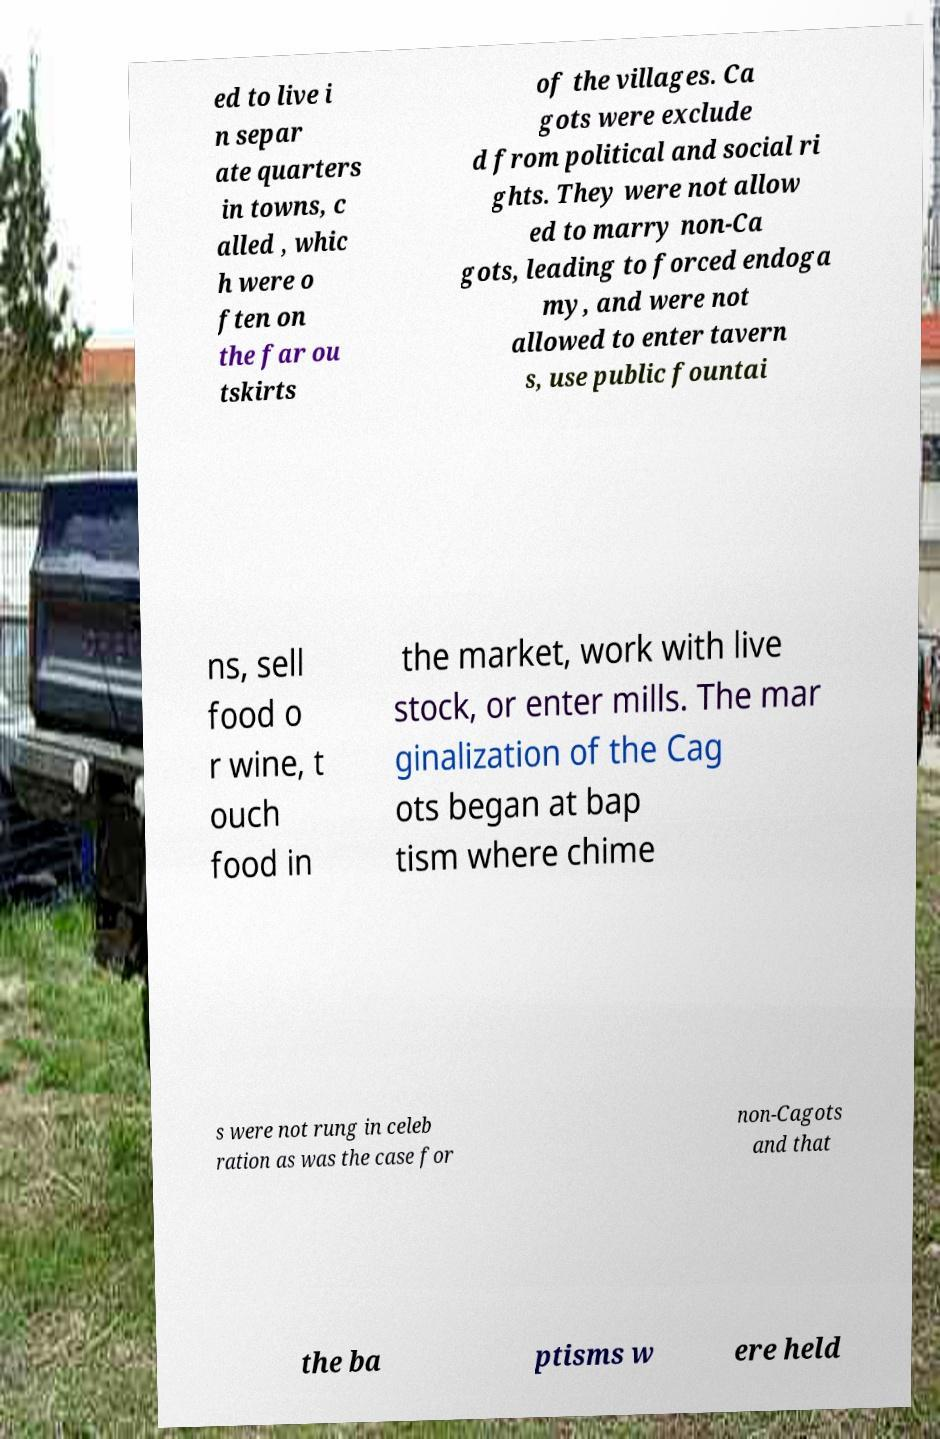Please read and relay the text visible in this image. What does it say? ed to live i n separ ate quarters in towns, c alled , whic h were o ften on the far ou tskirts of the villages. Ca gots were exclude d from political and social ri ghts. They were not allow ed to marry non-Ca gots, leading to forced endoga my, and were not allowed to enter tavern s, use public fountai ns, sell food o r wine, t ouch food in the market, work with live stock, or enter mills. The mar ginalization of the Cag ots began at bap tism where chime s were not rung in celeb ration as was the case for non-Cagots and that the ba ptisms w ere held 